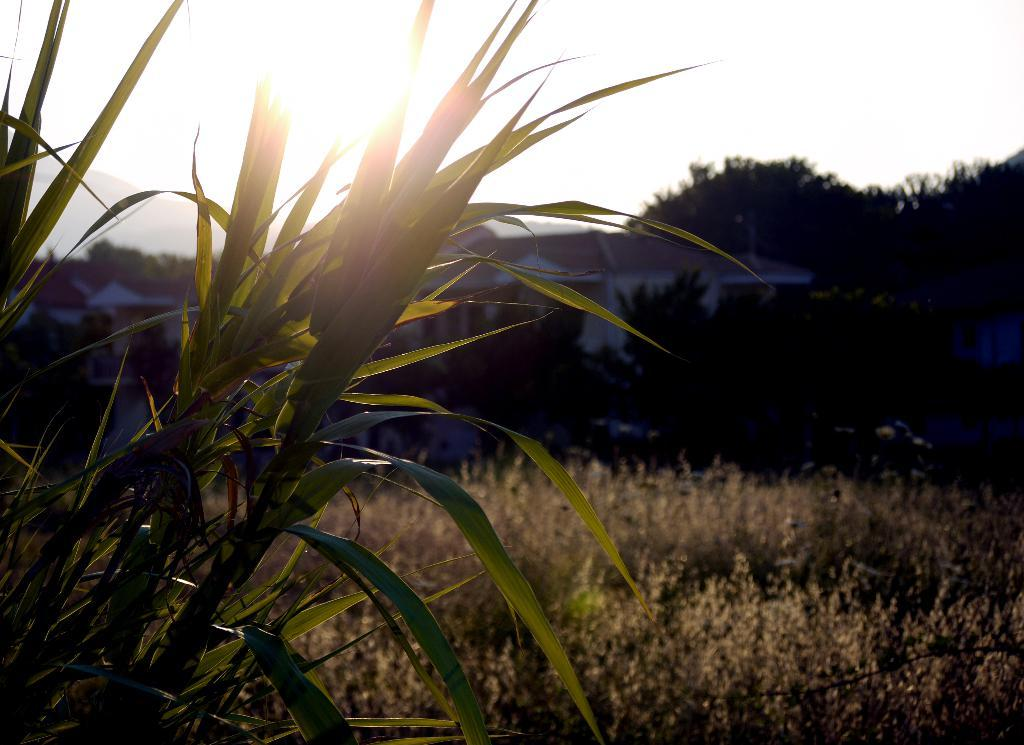What type of natural landform can be seen in the image? There are mountains in the image. What type of human-made structures are present in the image? There are houses in the image. What type of vegetation can be seen in the image? There are trees, bushes, plants, and grass in the image. What is the source of light visible in the image? There is sunlight visible at the top of the image in the sky. What type of legal advice can be seen being given in the image? There is no legal advice or lawyer present in the image; it features mountains, houses, trees, bushes, plants, grass, and sunlight. What type of amphibian can be seen hopping around in the image? There is no amphibian, such as a frog, present in the image. 